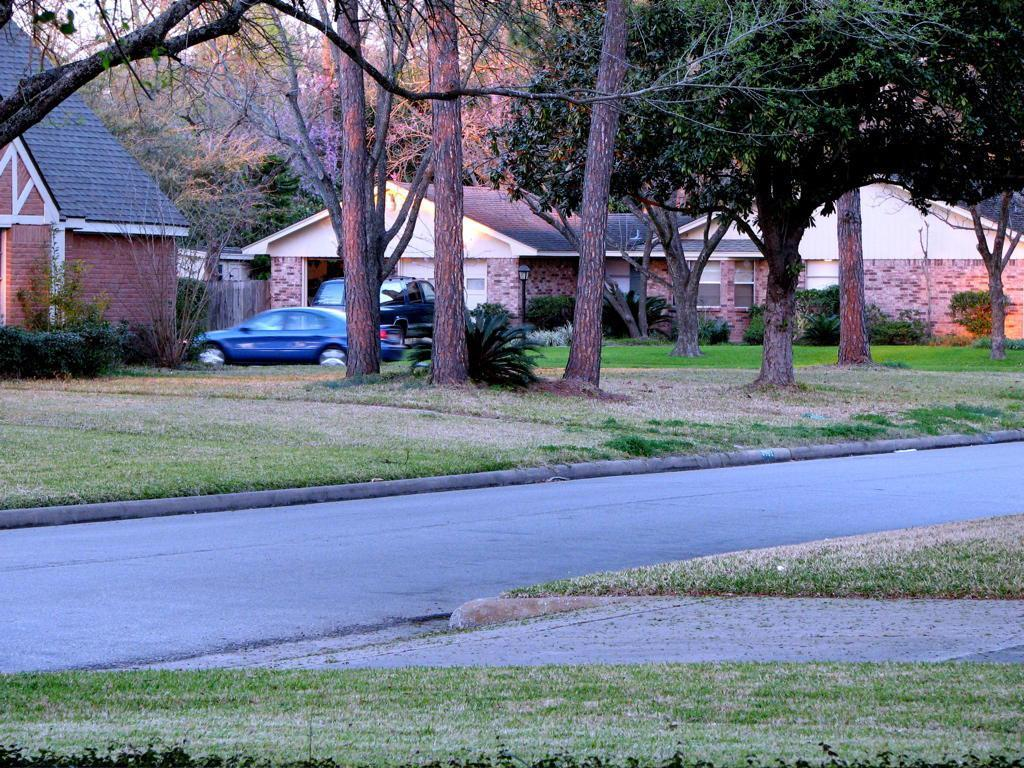What is the main feature in the center of the image? There is a road in the center of the image. What can be seen in the background of the image? There are houses, cars, and trees in the background of the image. What type of vegetation is at the bottom of the image? There is grass at the bottom of the image. Reasoning: Let' Let's think step by step in order to produce the conversation. We start by identifying the main feature in the image, which is the road. Then, we describe the background of the image, which includes houses, cars, and trees. Finally, we mention the type of vegetation at the bottom of the image, which is grass. Each question is designed to elicit a specific detail about the image that is known from the provided facts. Absurd Question/Answer: How many sisters are visible in the image? There are no sisters present in the image. What type of glass apparatus can be seen in the image? There is no glass apparatus present in the image. How many sisters are visible in the image? There are no sisters present in the image. What type of glass apparatus can be seen in the image? There is no glass apparatus present in the image. 